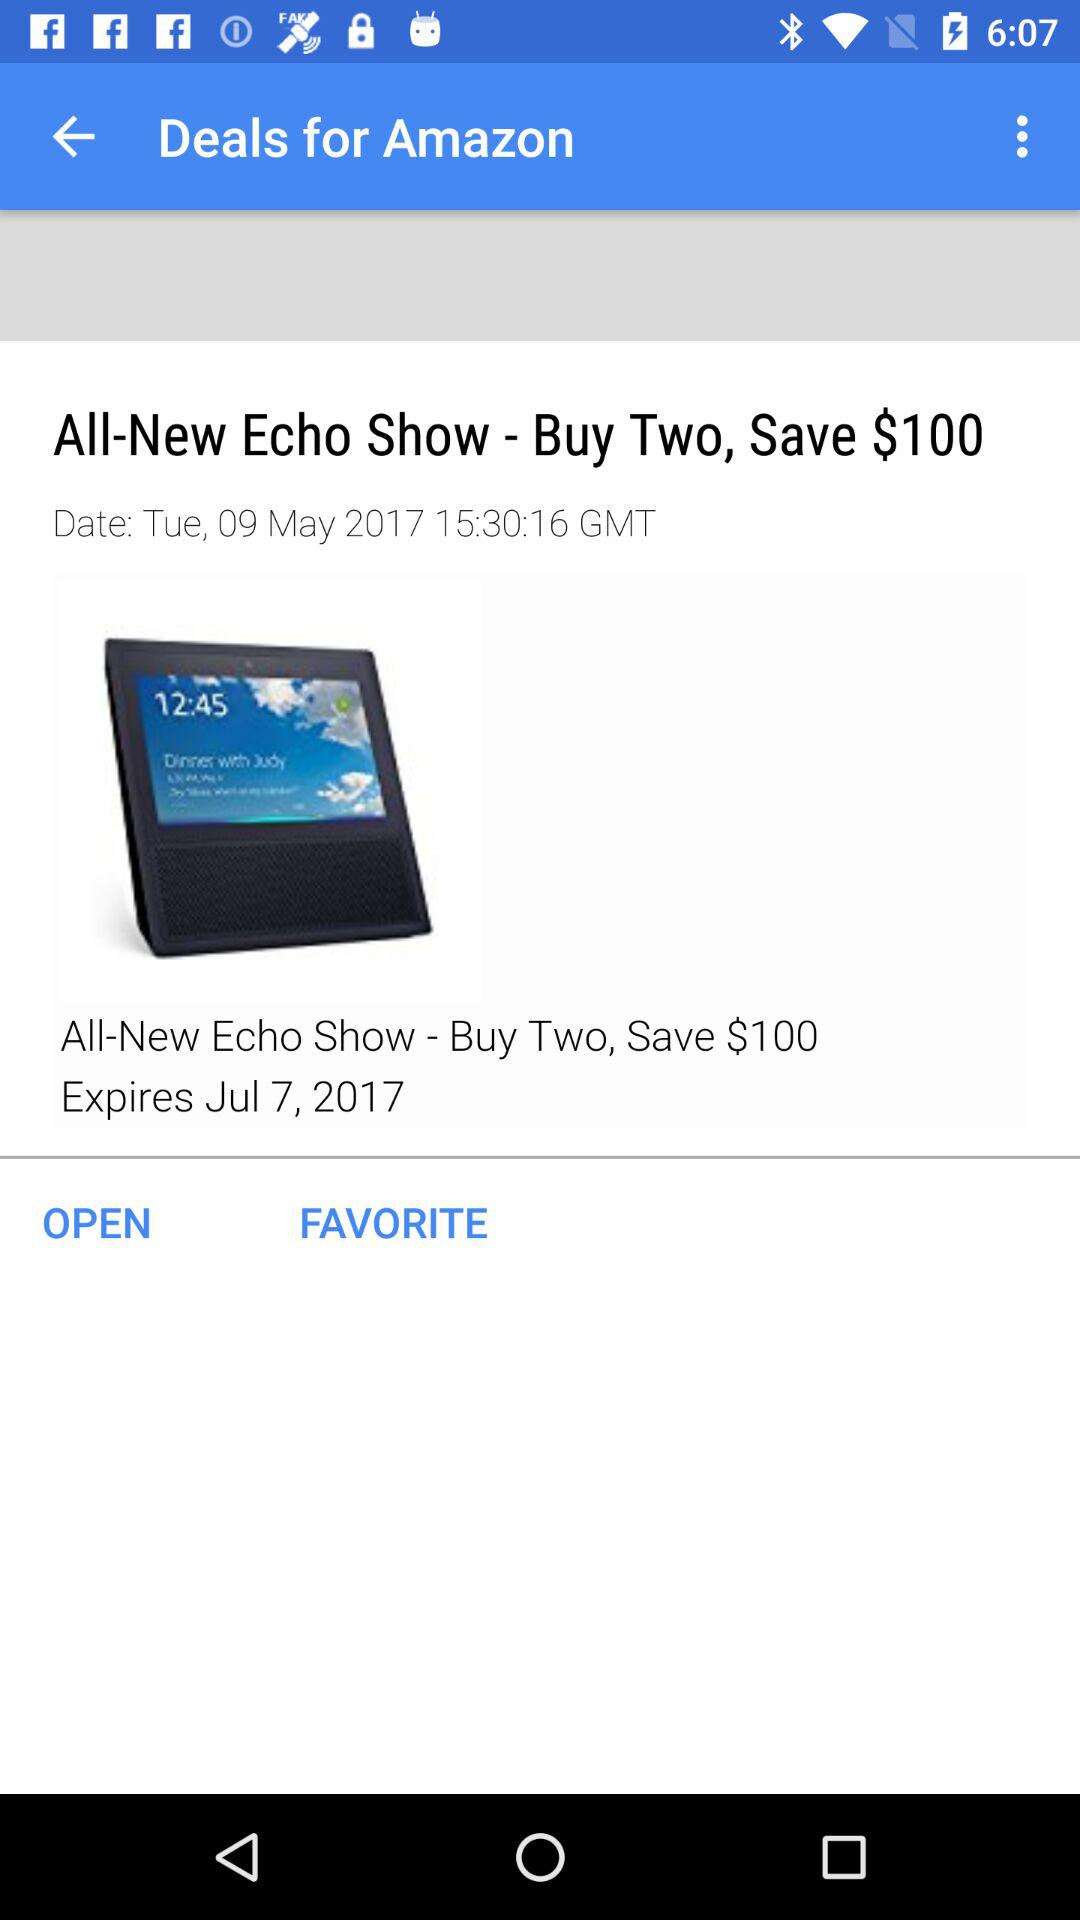What is the current date? The current date is Tuesday, May 9, 2017. 